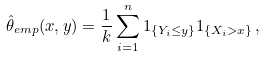Convert formula to latex. <formula><loc_0><loc_0><loc_500><loc_500>\hat { \theta } _ { e m p } ( x , y ) = \frac { 1 } { k } \sum _ { i = 1 } ^ { n } 1 _ { \{ Y _ { i } \leq y \} } 1 _ { \{ X _ { i } > x \} } \, ,</formula> 